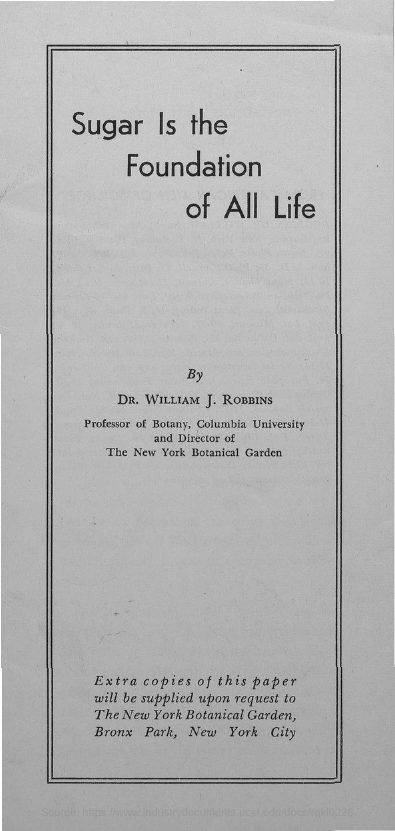Point out several critical features in this image. Sugar is the foundation of all life," declares the title of the document. 